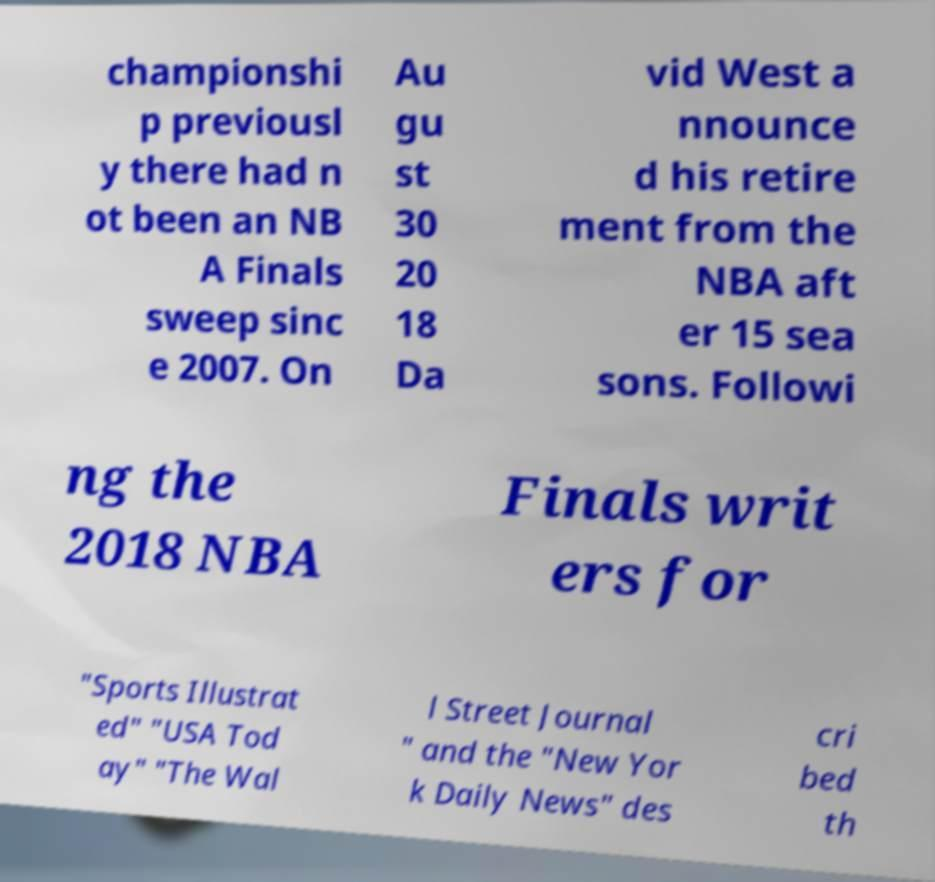There's text embedded in this image that I need extracted. Can you transcribe it verbatim? championshi p previousl y there had n ot been an NB A Finals sweep sinc e 2007. On Au gu st 30 20 18 Da vid West a nnounce d his retire ment from the NBA aft er 15 sea sons. Followi ng the 2018 NBA Finals writ ers for "Sports Illustrat ed" "USA Tod ay" "The Wal l Street Journal " and the "New Yor k Daily News" des cri bed th 